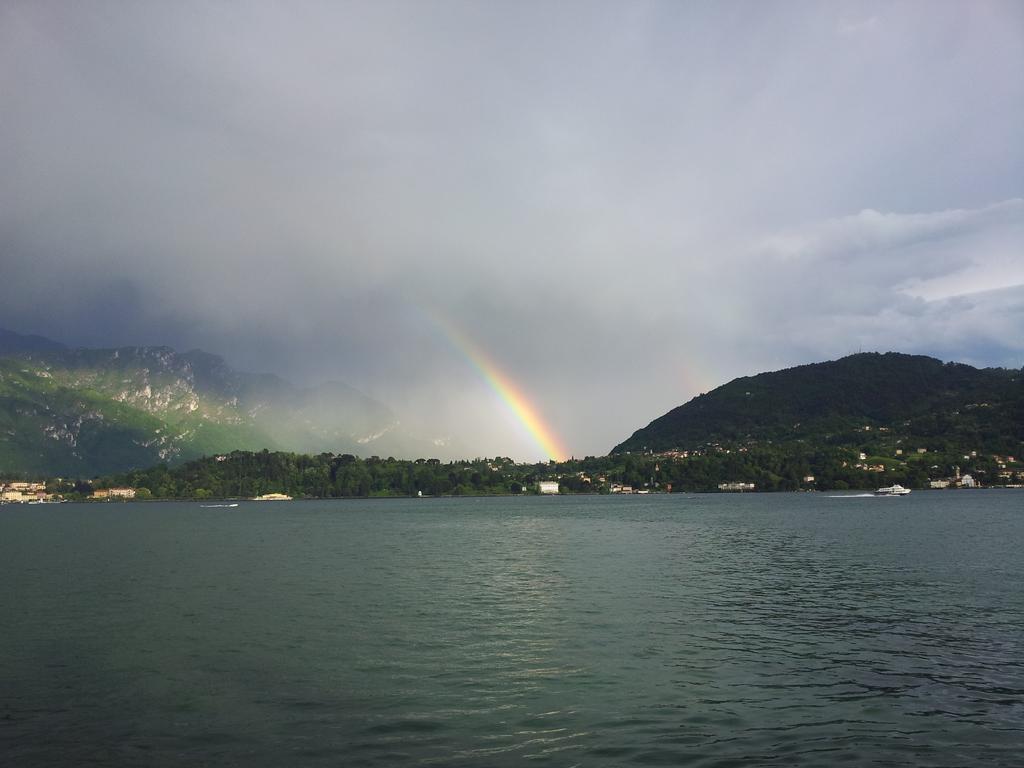Please provide a concise description of this image. This picture shows water and trees and we see few houses and few boats in the water and we see hills and a cloudy sky and we see a rainbow. 